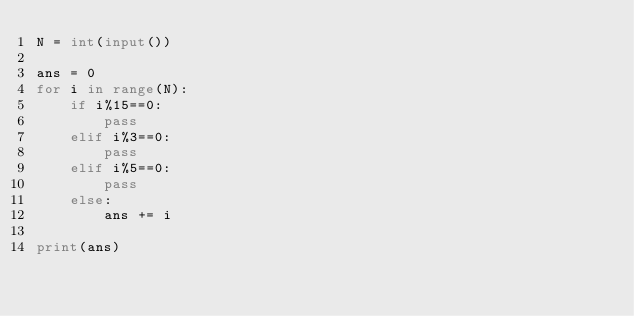Convert code to text. <code><loc_0><loc_0><loc_500><loc_500><_Python_>N = int(input())

ans = 0
for i in range(N):
    if i%15==0:
        pass
    elif i%3==0:
        pass
    elif i%5==0:
        pass
    else:
        ans += i

print(ans)</code> 